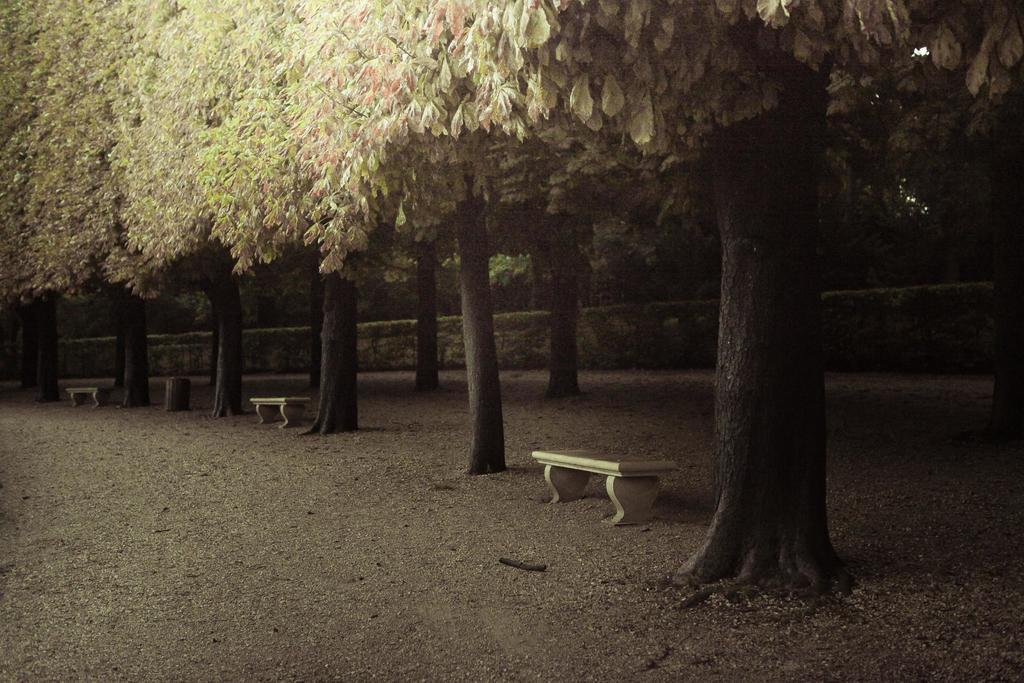What objects are in the foreground of the image? There are benches in the foreground of the image. How are the benches positioned in relation to the ground? The benches are placed on the ground. What can be seen in the center of the image? There is a group of trees and plants in the center of the image. Who is the creator of the trees and plants in the image? The image does not provide information about the creator of the trees and plants. 